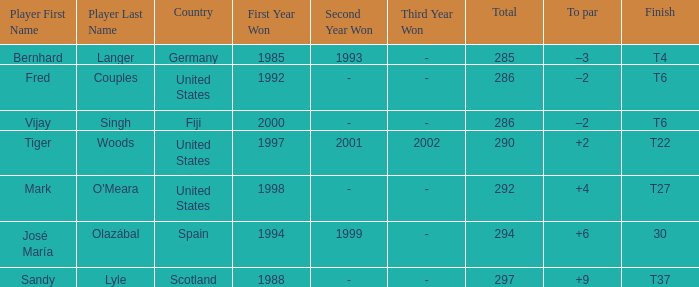What is the total for Bernhard Langer? 1.0. 